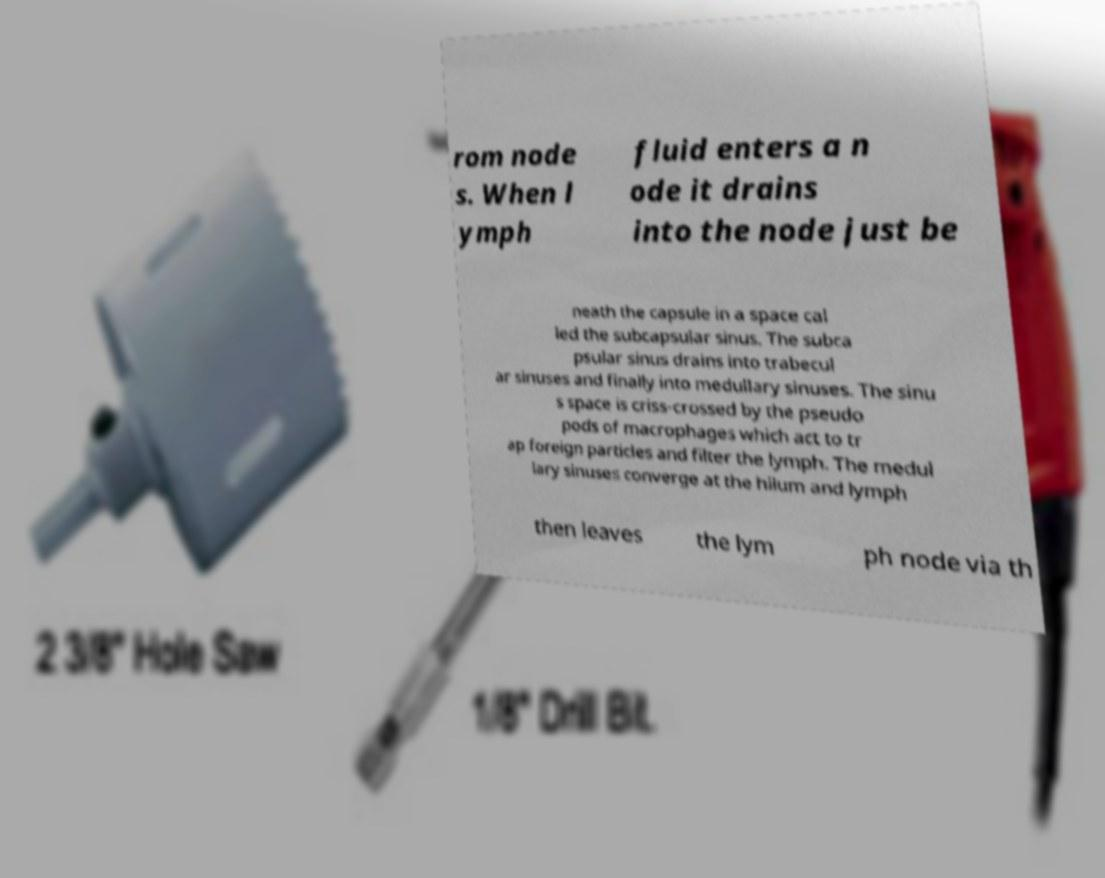For documentation purposes, I need the text within this image transcribed. Could you provide that? rom node s. When l ymph fluid enters a n ode it drains into the node just be neath the capsule in a space cal led the subcapsular sinus. The subca psular sinus drains into trabecul ar sinuses and finally into medullary sinuses. The sinu s space is criss-crossed by the pseudo pods of macrophages which act to tr ap foreign particles and filter the lymph. The medul lary sinuses converge at the hilum and lymph then leaves the lym ph node via th 